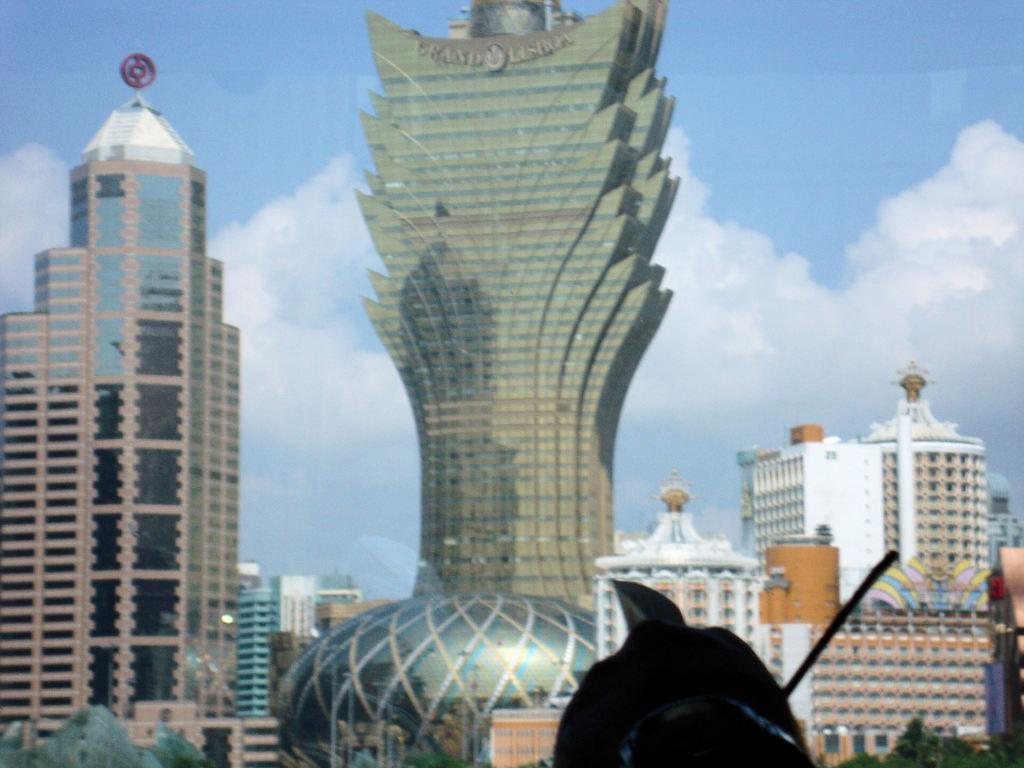What type of structures can be seen in the image? There are buildings in the image. What is located at the bottom of the image? There is a black color object at the bottom of the image. What can be seen in the background of the image? The sky is visible in the background of the image. What is present in the sky? Clouds are present in the sky. What type of bell can be seen hanging from the gold object in the image? There is no bell or gold object present in the image. 